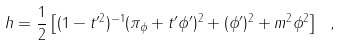Convert formula to latex. <formula><loc_0><loc_0><loc_500><loc_500>h = \frac { 1 } { 2 } \left [ ( 1 - t ^ { \prime 2 } ) ^ { - 1 } ( \pi _ { \phi } + t ^ { \prime } \phi ^ { \prime } ) ^ { 2 } + ( \phi ^ { \prime } ) ^ { 2 } + m ^ { 2 } \phi ^ { 2 } \right ] \ ,</formula> 